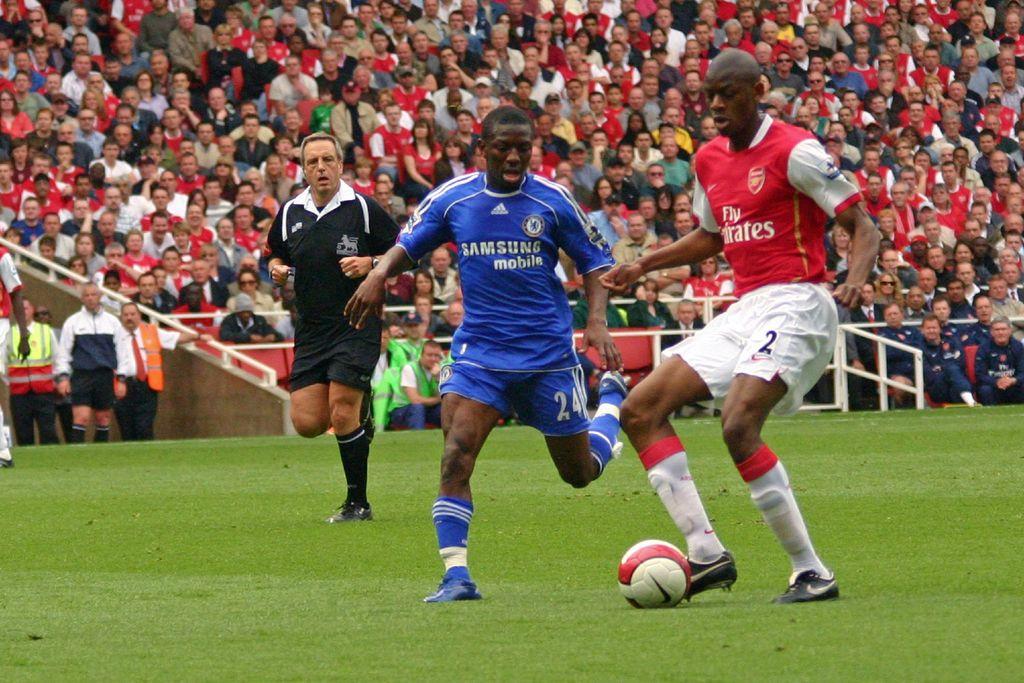What brand sponsors this blue jersey?
Provide a short and direct response. Samsung. What is one of the words on the red jersey?
Your answer should be very brief. Fly. 